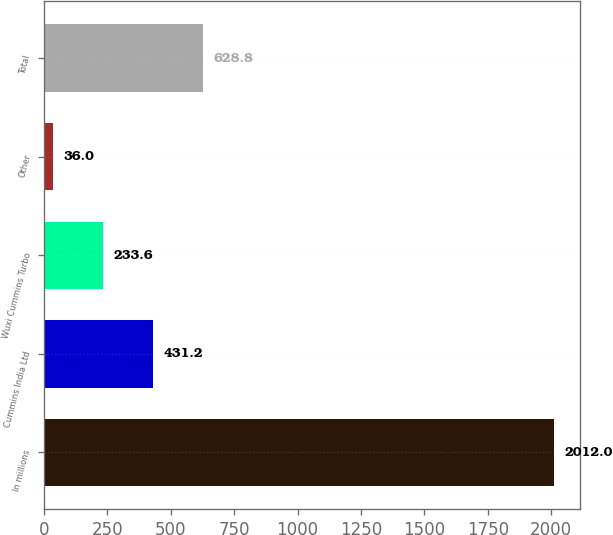<chart> <loc_0><loc_0><loc_500><loc_500><bar_chart><fcel>In millions<fcel>Cummins India Ltd<fcel>Wuxi Cummins Turbo<fcel>Other<fcel>Total<nl><fcel>2012<fcel>431.2<fcel>233.6<fcel>36<fcel>628.8<nl></chart> 